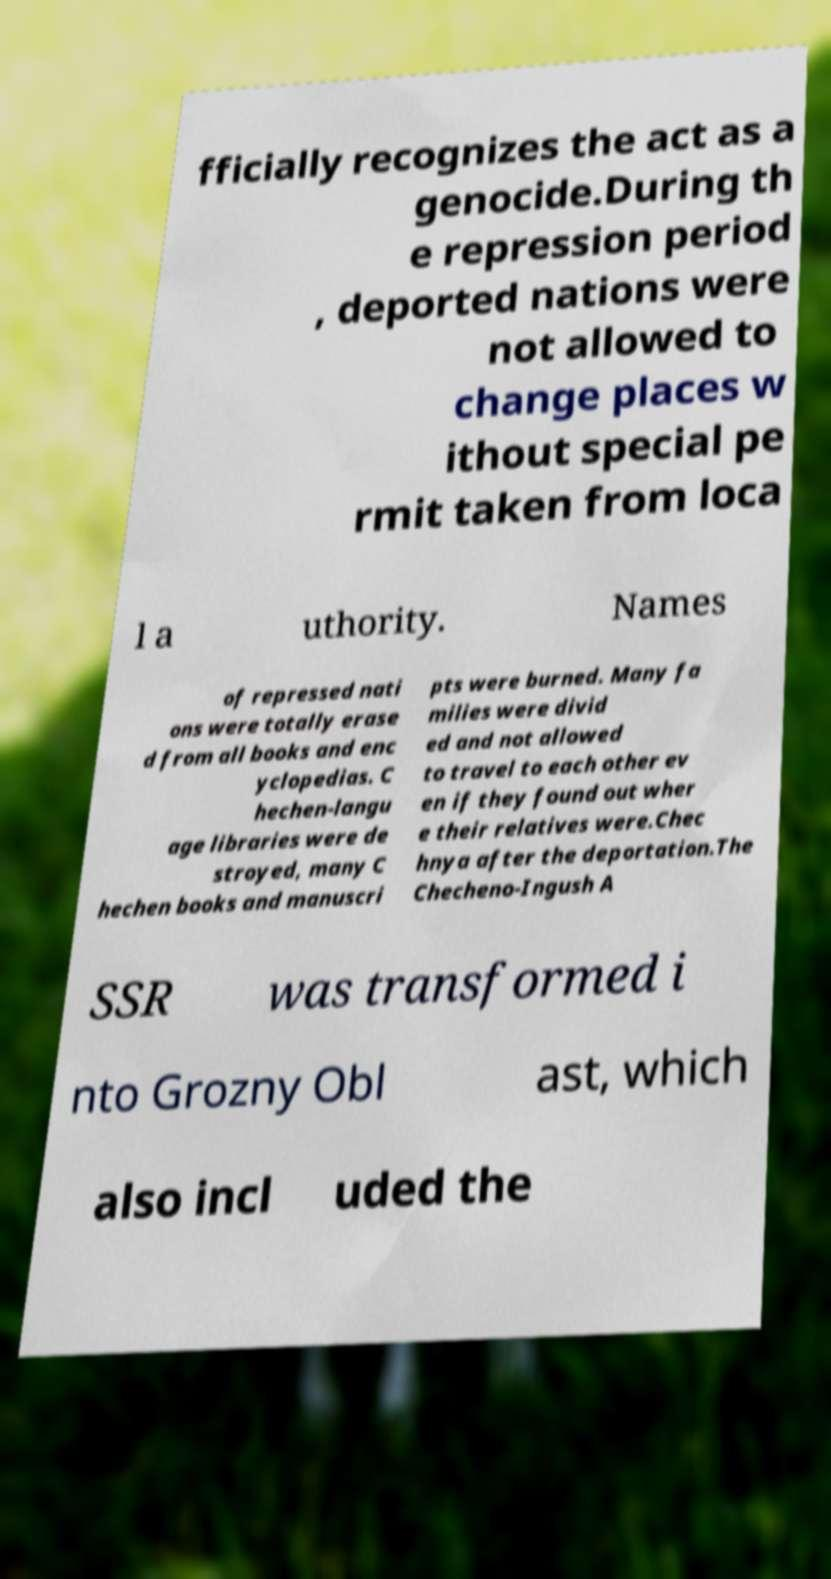What messages or text are displayed in this image? I need them in a readable, typed format. fficially recognizes the act as a genocide.During th e repression period , deported nations were not allowed to change places w ithout special pe rmit taken from loca l a uthority. Names of repressed nati ons were totally erase d from all books and enc yclopedias. C hechen-langu age libraries were de stroyed, many C hechen books and manuscri pts were burned. Many fa milies were divid ed and not allowed to travel to each other ev en if they found out wher e their relatives were.Chec hnya after the deportation.The Checheno-Ingush A SSR was transformed i nto Grozny Obl ast, which also incl uded the 